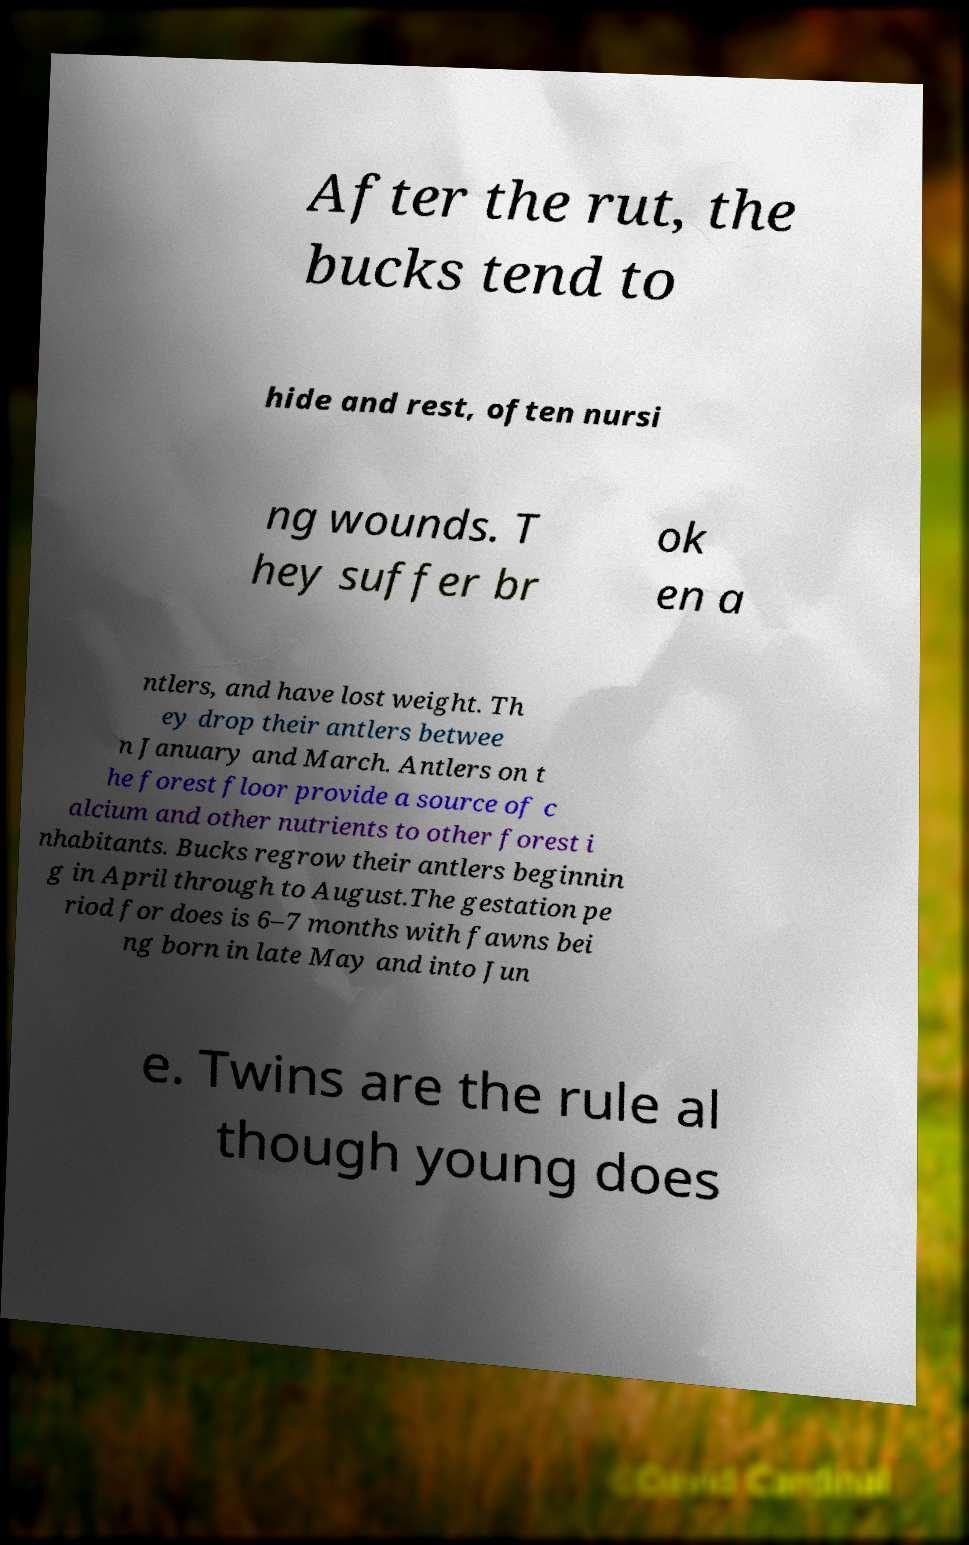Can you read and provide the text displayed in the image?This photo seems to have some interesting text. Can you extract and type it out for me? After the rut, the bucks tend to hide and rest, often nursi ng wounds. T hey suffer br ok en a ntlers, and have lost weight. Th ey drop their antlers betwee n January and March. Antlers on t he forest floor provide a source of c alcium and other nutrients to other forest i nhabitants. Bucks regrow their antlers beginnin g in April through to August.The gestation pe riod for does is 6–7 months with fawns bei ng born in late May and into Jun e. Twins are the rule al though young does 